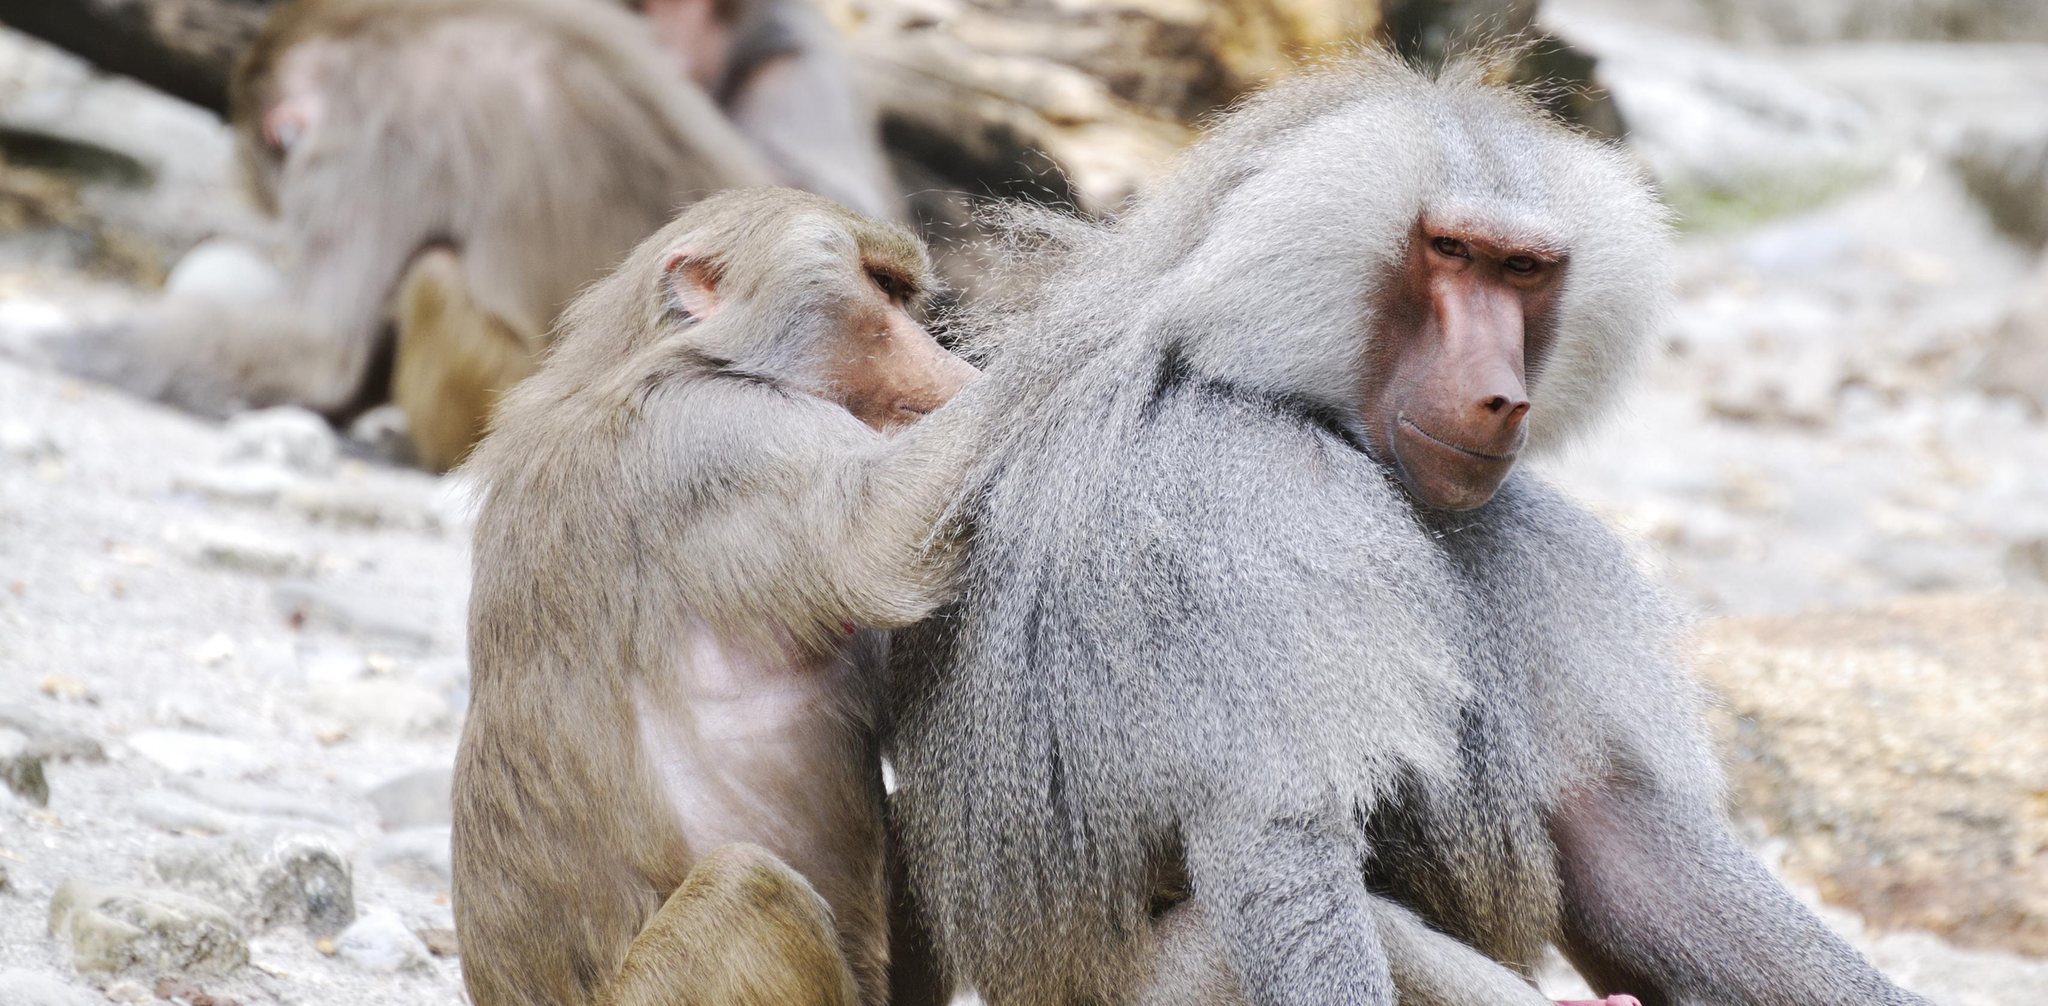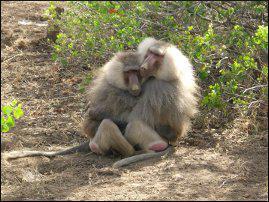The first image is the image on the left, the second image is the image on the right. For the images displayed, is the sentence "Exactly two baboons are in the foreground in at least one image." factually correct? Answer yes or no. Yes. 